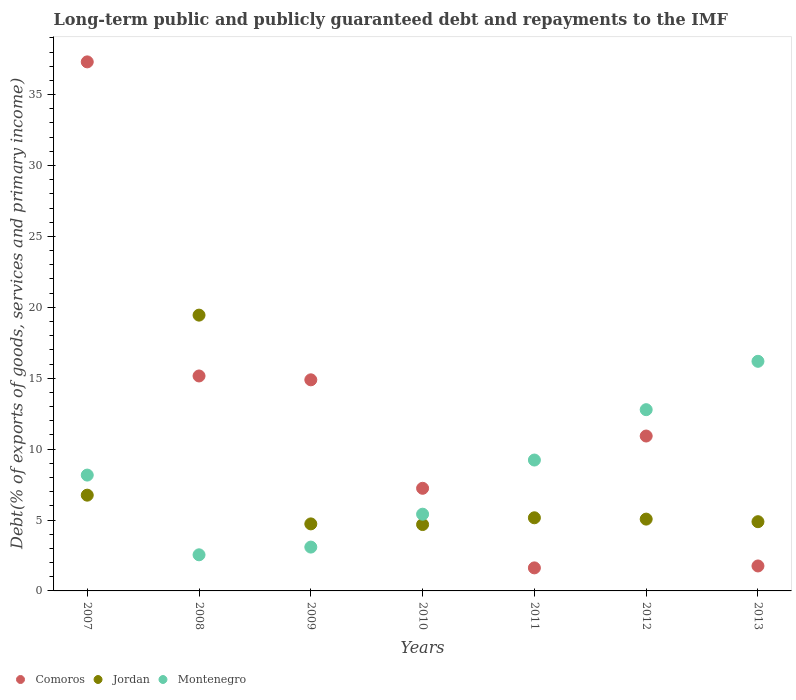How many different coloured dotlines are there?
Your response must be concise. 3. Is the number of dotlines equal to the number of legend labels?
Your answer should be compact. Yes. What is the debt and repayments in Jordan in 2013?
Provide a short and direct response. 4.88. Across all years, what is the maximum debt and repayments in Comoros?
Provide a succinct answer. 37.31. Across all years, what is the minimum debt and repayments in Montenegro?
Your answer should be very brief. 2.55. In which year was the debt and repayments in Jordan maximum?
Offer a terse response. 2008. In which year was the debt and repayments in Comoros minimum?
Provide a short and direct response. 2011. What is the total debt and repayments in Montenegro in the graph?
Make the answer very short. 57.42. What is the difference between the debt and repayments in Jordan in 2008 and that in 2012?
Give a very brief answer. 14.38. What is the difference between the debt and repayments in Comoros in 2011 and the debt and repayments in Jordan in 2012?
Your answer should be compact. -3.44. What is the average debt and repayments in Comoros per year?
Offer a very short reply. 12.7. In the year 2013, what is the difference between the debt and repayments in Comoros and debt and repayments in Montenegro?
Ensure brevity in your answer.  -14.43. In how many years, is the debt and repayments in Jordan greater than 27 %?
Your answer should be very brief. 0. What is the ratio of the debt and repayments in Jordan in 2011 to that in 2013?
Ensure brevity in your answer.  1.06. Is the difference between the debt and repayments in Comoros in 2007 and 2012 greater than the difference between the debt and repayments in Montenegro in 2007 and 2012?
Ensure brevity in your answer.  Yes. What is the difference between the highest and the second highest debt and repayments in Montenegro?
Provide a short and direct response. 3.41. What is the difference between the highest and the lowest debt and repayments in Comoros?
Your response must be concise. 35.68. In how many years, is the debt and repayments in Montenegro greater than the average debt and repayments in Montenegro taken over all years?
Offer a terse response. 3. Is the sum of the debt and repayments in Comoros in 2008 and 2010 greater than the maximum debt and repayments in Montenegro across all years?
Keep it short and to the point. Yes. Is it the case that in every year, the sum of the debt and repayments in Jordan and debt and repayments in Montenegro  is greater than the debt and repayments in Comoros?
Your answer should be compact. No. Are the values on the major ticks of Y-axis written in scientific E-notation?
Your answer should be very brief. No. How many legend labels are there?
Keep it short and to the point. 3. What is the title of the graph?
Offer a very short reply. Long-term public and publicly guaranteed debt and repayments to the IMF. Does "Greece" appear as one of the legend labels in the graph?
Provide a short and direct response. No. What is the label or title of the Y-axis?
Ensure brevity in your answer.  Debt(% of exports of goods, services and primary income). What is the Debt(% of exports of goods, services and primary income) in Comoros in 2007?
Keep it short and to the point. 37.31. What is the Debt(% of exports of goods, services and primary income) in Jordan in 2007?
Provide a succinct answer. 6.75. What is the Debt(% of exports of goods, services and primary income) in Montenegro in 2007?
Make the answer very short. 8.17. What is the Debt(% of exports of goods, services and primary income) of Comoros in 2008?
Your answer should be compact. 15.16. What is the Debt(% of exports of goods, services and primary income) of Jordan in 2008?
Provide a short and direct response. 19.45. What is the Debt(% of exports of goods, services and primary income) of Montenegro in 2008?
Provide a succinct answer. 2.55. What is the Debt(% of exports of goods, services and primary income) of Comoros in 2009?
Your answer should be very brief. 14.89. What is the Debt(% of exports of goods, services and primary income) in Jordan in 2009?
Make the answer very short. 4.73. What is the Debt(% of exports of goods, services and primary income) in Montenegro in 2009?
Your answer should be compact. 3.09. What is the Debt(% of exports of goods, services and primary income) of Comoros in 2010?
Offer a very short reply. 7.24. What is the Debt(% of exports of goods, services and primary income) of Jordan in 2010?
Ensure brevity in your answer.  4.68. What is the Debt(% of exports of goods, services and primary income) of Montenegro in 2010?
Make the answer very short. 5.41. What is the Debt(% of exports of goods, services and primary income) of Comoros in 2011?
Give a very brief answer. 1.62. What is the Debt(% of exports of goods, services and primary income) in Jordan in 2011?
Ensure brevity in your answer.  5.16. What is the Debt(% of exports of goods, services and primary income) in Montenegro in 2011?
Offer a very short reply. 9.23. What is the Debt(% of exports of goods, services and primary income) of Comoros in 2012?
Your response must be concise. 10.92. What is the Debt(% of exports of goods, services and primary income) in Jordan in 2012?
Your answer should be compact. 5.06. What is the Debt(% of exports of goods, services and primary income) of Montenegro in 2012?
Your answer should be very brief. 12.78. What is the Debt(% of exports of goods, services and primary income) of Comoros in 2013?
Offer a very short reply. 1.76. What is the Debt(% of exports of goods, services and primary income) in Jordan in 2013?
Provide a short and direct response. 4.88. What is the Debt(% of exports of goods, services and primary income) of Montenegro in 2013?
Make the answer very short. 16.19. Across all years, what is the maximum Debt(% of exports of goods, services and primary income) of Comoros?
Your answer should be compact. 37.31. Across all years, what is the maximum Debt(% of exports of goods, services and primary income) of Jordan?
Keep it short and to the point. 19.45. Across all years, what is the maximum Debt(% of exports of goods, services and primary income) of Montenegro?
Ensure brevity in your answer.  16.19. Across all years, what is the minimum Debt(% of exports of goods, services and primary income) of Comoros?
Your answer should be very brief. 1.62. Across all years, what is the minimum Debt(% of exports of goods, services and primary income) in Jordan?
Provide a short and direct response. 4.68. Across all years, what is the minimum Debt(% of exports of goods, services and primary income) in Montenegro?
Provide a succinct answer. 2.55. What is the total Debt(% of exports of goods, services and primary income) of Comoros in the graph?
Offer a terse response. 88.9. What is the total Debt(% of exports of goods, services and primary income) of Jordan in the graph?
Provide a succinct answer. 50.71. What is the total Debt(% of exports of goods, services and primary income) in Montenegro in the graph?
Your answer should be very brief. 57.42. What is the difference between the Debt(% of exports of goods, services and primary income) of Comoros in 2007 and that in 2008?
Keep it short and to the point. 22.15. What is the difference between the Debt(% of exports of goods, services and primary income) in Jordan in 2007 and that in 2008?
Your answer should be very brief. -12.7. What is the difference between the Debt(% of exports of goods, services and primary income) of Montenegro in 2007 and that in 2008?
Your response must be concise. 5.62. What is the difference between the Debt(% of exports of goods, services and primary income) in Comoros in 2007 and that in 2009?
Provide a short and direct response. 22.42. What is the difference between the Debt(% of exports of goods, services and primary income) of Jordan in 2007 and that in 2009?
Provide a succinct answer. 2.03. What is the difference between the Debt(% of exports of goods, services and primary income) in Montenegro in 2007 and that in 2009?
Offer a very short reply. 5.08. What is the difference between the Debt(% of exports of goods, services and primary income) of Comoros in 2007 and that in 2010?
Ensure brevity in your answer.  30.07. What is the difference between the Debt(% of exports of goods, services and primary income) in Jordan in 2007 and that in 2010?
Make the answer very short. 2.07. What is the difference between the Debt(% of exports of goods, services and primary income) in Montenegro in 2007 and that in 2010?
Your answer should be compact. 2.76. What is the difference between the Debt(% of exports of goods, services and primary income) in Comoros in 2007 and that in 2011?
Offer a very short reply. 35.68. What is the difference between the Debt(% of exports of goods, services and primary income) of Jordan in 2007 and that in 2011?
Keep it short and to the point. 1.6. What is the difference between the Debt(% of exports of goods, services and primary income) of Montenegro in 2007 and that in 2011?
Offer a very short reply. -1.06. What is the difference between the Debt(% of exports of goods, services and primary income) in Comoros in 2007 and that in 2012?
Make the answer very short. 26.39. What is the difference between the Debt(% of exports of goods, services and primary income) in Jordan in 2007 and that in 2012?
Provide a short and direct response. 1.69. What is the difference between the Debt(% of exports of goods, services and primary income) in Montenegro in 2007 and that in 2012?
Your answer should be very brief. -4.61. What is the difference between the Debt(% of exports of goods, services and primary income) in Comoros in 2007 and that in 2013?
Ensure brevity in your answer.  35.55. What is the difference between the Debt(% of exports of goods, services and primary income) in Jordan in 2007 and that in 2013?
Offer a terse response. 1.87. What is the difference between the Debt(% of exports of goods, services and primary income) in Montenegro in 2007 and that in 2013?
Make the answer very short. -8.02. What is the difference between the Debt(% of exports of goods, services and primary income) of Comoros in 2008 and that in 2009?
Give a very brief answer. 0.27. What is the difference between the Debt(% of exports of goods, services and primary income) in Jordan in 2008 and that in 2009?
Provide a short and direct response. 14.72. What is the difference between the Debt(% of exports of goods, services and primary income) of Montenegro in 2008 and that in 2009?
Provide a short and direct response. -0.54. What is the difference between the Debt(% of exports of goods, services and primary income) in Comoros in 2008 and that in 2010?
Offer a very short reply. 7.92. What is the difference between the Debt(% of exports of goods, services and primary income) in Jordan in 2008 and that in 2010?
Your answer should be very brief. 14.77. What is the difference between the Debt(% of exports of goods, services and primary income) in Montenegro in 2008 and that in 2010?
Offer a terse response. -2.86. What is the difference between the Debt(% of exports of goods, services and primary income) of Comoros in 2008 and that in 2011?
Offer a very short reply. 13.53. What is the difference between the Debt(% of exports of goods, services and primary income) of Jordan in 2008 and that in 2011?
Ensure brevity in your answer.  14.29. What is the difference between the Debt(% of exports of goods, services and primary income) in Montenegro in 2008 and that in 2011?
Offer a terse response. -6.68. What is the difference between the Debt(% of exports of goods, services and primary income) of Comoros in 2008 and that in 2012?
Your answer should be very brief. 4.24. What is the difference between the Debt(% of exports of goods, services and primary income) in Jordan in 2008 and that in 2012?
Your response must be concise. 14.38. What is the difference between the Debt(% of exports of goods, services and primary income) in Montenegro in 2008 and that in 2012?
Keep it short and to the point. -10.24. What is the difference between the Debt(% of exports of goods, services and primary income) of Comoros in 2008 and that in 2013?
Give a very brief answer. 13.4. What is the difference between the Debt(% of exports of goods, services and primary income) in Jordan in 2008 and that in 2013?
Offer a terse response. 14.57. What is the difference between the Debt(% of exports of goods, services and primary income) of Montenegro in 2008 and that in 2013?
Provide a succinct answer. -13.65. What is the difference between the Debt(% of exports of goods, services and primary income) of Comoros in 2009 and that in 2010?
Offer a very short reply. 7.65. What is the difference between the Debt(% of exports of goods, services and primary income) in Jordan in 2009 and that in 2010?
Your response must be concise. 0.05. What is the difference between the Debt(% of exports of goods, services and primary income) in Montenegro in 2009 and that in 2010?
Make the answer very short. -2.32. What is the difference between the Debt(% of exports of goods, services and primary income) of Comoros in 2009 and that in 2011?
Keep it short and to the point. 13.26. What is the difference between the Debt(% of exports of goods, services and primary income) of Jordan in 2009 and that in 2011?
Keep it short and to the point. -0.43. What is the difference between the Debt(% of exports of goods, services and primary income) of Montenegro in 2009 and that in 2011?
Provide a succinct answer. -6.14. What is the difference between the Debt(% of exports of goods, services and primary income) of Comoros in 2009 and that in 2012?
Your answer should be very brief. 3.96. What is the difference between the Debt(% of exports of goods, services and primary income) of Jordan in 2009 and that in 2012?
Offer a very short reply. -0.34. What is the difference between the Debt(% of exports of goods, services and primary income) in Montenegro in 2009 and that in 2012?
Your answer should be very brief. -9.69. What is the difference between the Debt(% of exports of goods, services and primary income) in Comoros in 2009 and that in 2013?
Your response must be concise. 13.13. What is the difference between the Debt(% of exports of goods, services and primary income) in Jordan in 2009 and that in 2013?
Keep it short and to the point. -0.15. What is the difference between the Debt(% of exports of goods, services and primary income) of Montenegro in 2009 and that in 2013?
Keep it short and to the point. -13.1. What is the difference between the Debt(% of exports of goods, services and primary income) in Comoros in 2010 and that in 2011?
Offer a terse response. 5.61. What is the difference between the Debt(% of exports of goods, services and primary income) of Jordan in 2010 and that in 2011?
Keep it short and to the point. -0.48. What is the difference between the Debt(% of exports of goods, services and primary income) in Montenegro in 2010 and that in 2011?
Make the answer very short. -3.82. What is the difference between the Debt(% of exports of goods, services and primary income) of Comoros in 2010 and that in 2012?
Ensure brevity in your answer.  -3.69. What is the difference between the Debt(% of exports of goods, services and primary income) in Jordan in 2010 and that in 2012?
Ensure brevity in your answer.  -0.38. What is the difference between the Debt(% of exports of goods, services and primary income) of Montenegro in 2010 and that in 2012?
Your response must be concise. -7.37. What is the difference between the Debt(% of exports of goods, services and primary income) of Comoros in 2010 and that in 2013?
Offer a terse response. 5.48. What is the difference between the Debt(% of exports of goods, services and primary income) in Jordan in 2010 and that in 2013?
Provide a succinct answer. -0.2. What is the difference between the Debt(% of exports of goods, services and primary income) of Montenegro in 2010 and that in 2013?
Provide a succinct answer. -10.78. What is the difference between the Debt(% of exports of goods, services and primary income) in Comoros in 2011 and that in 2012?
Make the answer very short. -9.3. What is the difference between the Debt(% of exports of goods, services and primary income) in Jordan in 2011 and that in 2012?
Your answer should be compact. 0.09. What is the difference between the Debt(% of exports of goods, services and primary income) in Montenegro in 2011 and that in 2012?
Give a very brief answer. -3.55. What is the difference between the Debt(% of exports of goods, services and primary income) of Comoros in 2011 and that in 2013?
Offer a very short reply. -0.14. What is the difference between the Debt(% of exports of goods, services and primary income) of Jordan in 2011 and that in 2013?
Your answer should be compact. 0.28. What is the difference between the Debt(% of exports of goods, services and primary income) in Montenegro in 2011 and that in 2013?
Offer a very short reply. -6.96. What is the difference between the Debt(% of exports of goods, services and primary income) in Comoros in 2012 and that in 2013?
Offer a very short reply. 9.16. What is the difference between the Debt(% of exports of goods, services and primary income) in Jordan in 2012 and that in 2013?
Ensure brevity in your answer.  0.18. What is the difference between the Debt(% of exports of goods, services and primary income) of Montenegro in 2012 and that in 2013?
Your answer should be very brief. -3.41. What is the difference between the Debt(% of exports of goods, services and primary income) of Comoros in 2007 and the Debt(% of exports of goods, services and primary income) of Jordan in 2008?
Your answer should be very brief. 17.86. What is the difference between the Debt(% of exports of goods, services and primary income) in Comoros in 2007 and the Debt(% of exports of goods, services and primary income) in Montenegro in 2008?
Make the answer very short. 34.76. What is the difference between the Debt(% of exports of goods, services and primary income) in Jordan in 2007 and the Debt(% of exports of goods, services and primary income) in Montenegro in 2008?
Your response must be concise. 4.21. What is the difference between the Debt(% of exports of goods, services and primary income) of Comoros in 2007 and the Debt(% of exports of goods, services and primary income) of Jordan in 2009?
Keep it short and to the point. 32.58. What is the difference between the Debt(% of exports of goods, services and primary income) of Comoros in 2007 and the Debt(% of exports of goods, services and primary income) of Montenegro in 2009?
Offer a terse response. 34.22. What is the difference between the Debt(% of exports of goods, services and primary income) of Jordan in 2007 and the Debt(% of exports of goods, services and primary income) of Montenegro in 2009?
Make the answer very short. 3.66. What is the difference between the Debt(% of exports of goods, services and primary income) of Comoros in 2007 and the Debt(% of exports of goods, services and primary income) of Jordan in 2010?
Provide a succinct answer. 32.63. What is the difference between the Debt(% of exports of goods, services and primary income) in Comoros in 2007 and the Debt(% of exports of goods, services and primary income) in Montenegro in 2010?
Offer a very short reply. 31.9. What is the difference between the Debt(% of exports of goods, services and primary income) of Jordan in 2007 and the Debt(% of exports of goods, services and primary income) of Montenegro in 2010?
Make the answer very short. 1.34. What is the difference between the Debt(% of exports of goods, services and primary income) in Comoros in 2007 and the Debt(% of exports of goods, services and primary income) in Jordan in 2011?
Keep it short and to the point. 32.15. What is the difference between the Debt(% of exports of goods, services and primary income) of Comoros in 2007 and the Debt(% of exports of goods, services and primary income) of Montenegro in 2011?
Give a very brief answer. 28.08. What is the difference between the Debt(% of exports of goods, services and primary income) of Jordan in 2007 and the Debt(% of exports of goods, services and primary income) of Montenegro in 2011?
Your answer should be very brief. -2.48. What is the difference between the Debt(% of exports of goods, services and primary income) of Comoros in 2007 and the Debt(% of exports of goods, services and primary income) of Jordan in 2012?
Ensure brevity in your answer.  32.24. What is the difference between the Debt(% of exports of goods, services and primary income) in Comoros in 2007 and the Debt(% of exports of goods, services and primary income) in Montenegro in 2012?
Your answer should be very brief. 24.53. What is the difference between the Debt(% of exports of goods, services and primary income) of Jordan in 2007 and the Debt(% of exports of goods, services and primary income) of Montenegro in 2012?
Keep it short and to the point. -6.03. What is the difference between the Debt(% of exports of goods, services and primary income) in Comoros in 2007 and the Debt(% of exports of goods, services and primary income) in Jordan in 2013?
Keep it short and to the point. 32.43. What is the difference between the Debt(% of exports of goods, services and primary income) in Comoros in 2007 and the Debt(% of exports of goods, services and primary income) in Montenegro in 2013?
Give a very brief answer. 21.12. What is the difference between the Debt(% of exports of goods, services and primary income) in Jordan in 2007 and the Debt(% of exports of goods, services and primary income) in Montenegro in 2013?
Your answer should be compact. -9.44. What is the difference between the Debt(% of exports of goods, services and primary income) of Comoros in 2008 and the Debt(% of exports of goods, services and primary income) of Jordan in 2009?
Give a very brief answer. 10.43. What is the difference between the Debt(% of exports of goods, services and primary income) in Comoros in 2008 and the Debt(% of exports of goods, services and primary income) in Montenegro in 2009?
Provide a succinct answer. 12.07. What is the difference between the Debt(% of exports of goods, services and primary income) of Jordan in 2008 and the Debt(% of exports of goods, services and primary income) of Montenegro in 2009?
Your answer should be compact. 16.36. What is the difference between the Debt(% of exports of goods, services and primary income) of Comoros in 2008 and the Debt(% of exports of goods, services and primary income) of Jordan in 2010?
Ensure brevity in your answer.  10.48. What is the difference between the Debt(% of exports of goods, services and primary income) in Comoros in 2008 and the Debt(% of exports of goods, services and primary income) in Montenegro in 2010?
Your answer should be very brief. 9.75. What is the difference between the Debt(% of exports of goods, services and primary income) of Jordan in 2008 and the Debt(% of exports of goods, services and primary income) of Montenegro in 2010?
Offer a very short reply. 14.04. What is the difference between the Debt(% of exports of goods, services and primary income) of Comoros in 2008 and the Debt(% of exports of goods, services and primary income) of Jordan in 2011?
Keep it short and to the point. 10. What is the difference between the Debt(% of exports of goods, services and primary income) in Comoros in 2008 and the Debt(% of exports of goods, services and primary income) in Montenegro in 2011?
Offer a terse response. 5.93. What is the difference between the Debt(% of exports of goods, services and primary income) of Jordan in 2008 and the Debt(% of exports of goods, services and primary income) of Montenegro in 2011?
Your response must be concise. 10.22. What is the difference between the Debt(% of exports of goods, services and primary income) in Comoros in 2008 and the Debt(% of exports of goods, services and primary income) in Jordan in 2012?
Provide a succinct answer. 10.09. What is the difference between the Debt(% of exports of goods, services and primary income) in Comoros in 2008 and the Debt(% of exports of goods, services and primary income) in Montenegro in 2012?
Provide a short and direct response. 2.38. What is the difference between the Debt(% of exports of goods, services and primary income) in Jordan in 2008 and the Debt(% of exports of goods, services and primary income) in Montenegro in 2012?
Your response must be concise. 6.67. What is the difference between the Debt(% of exports of goods, services and primary income) of Comoros in 2008 and the Debt(% of exports of goods, services and primary income) of Jordan in 2013?
Your answer should be compact. 10.28. What is the difference between the Debt(% of exports of goods, services and primary income) of Comoros in 2008 and the Debt(% of exports of goods, services and primary income) of Montenegro in 2013?
Offer a terse response. -1.03. What is the difference between the Debt(% of exports of goods, services and primary income) of Jordan in 2008 and the Debt(% of exports of goods, services and primary income) of Montenegro in 2013?
Your response must be concise. 3.26. What is the difference between the Debt(% of exports of goods, services and primary income) of Comoros in 2009 and the Debt(% of exports of goods, services and primary income) of Jordan in 2010?
Give a very brief answer. 10.21. What is the difference between the Debt(% of exports of goods, services and primary income) in Comoros in 2009 and the Debt(% of exports of goods, services and primary income) in Montenegro in 2010?
Provide a succinct answer. 9.48. What is the difference between the Debt(% of exports of goods, services and primary income) in Jordan in 2009 and the Debt(% of exports of goods, services and primary income) in Montenegro in 2010?
Make the answer very short. -0.68. What is the difference between the Debt(% of exports of goods, services and primary income) in Comoros in 2009 and the Debt(% of exports of goods, services and primary income) in Jordan in 2011?
Ensure brevity in your answer.  9.73. What is the difference between the Debt(% of exports of goods, services and primary income) in Comoros in 2009 and the Debt(% of exports of goods, services and primary income) in Montenegro in 2011?
Offer a terse response. 5.66. What is the difference between the Debt(% of exports of goods, services and primary income) of Jordan in 2009 and the Debt(% of exports of goods, services and primary income) of Montenegro in 2011?
Your answer should be compact. -4.5. What is the difference between the Debt(% of exports of goods, services and primary income) in Comoros in 2009 and the Debt(% of exports of goods, services and primary income) in Jordan in 2012?
Offer a very short reply. 9.82. What is the difference between the Debt(% of exports of goods, services and primary income) of Comoros in 2009 and the Debt(% of exports of goods, services and primary income) of Montenegro in 2012?
Offer a very short reply. 2.11. What is the difference between the Debt(% of exports of goods, services and primary income) of Jordan in 2009 and the Debt(% of exports of goods, services and primary income) of Montenegro in 2012?
Provide a short and direct response. -8.05. What is the difference between the Debt(% of exports of goods, services and primary income) in Comoros in 2009 and the Debt(% of exports of goods, services and primary income) in Jordan in 2013?
Your response must be concise. 10.01. What is the difference between the Debt(% of exports of goods, services and primary income) of Comoros in 2009 and the Debt(% of exports of goods, services and primary income) of Montenegro in 2013?
Give a very brief answer. -1.31. What is the difference between the Debt(% of exports of goods, services and primary income) in Jordan in 2009 and the Debt(% of exports of goods, services and primary income) in Montenegro in 2013?
Provide a succinct answer. -11.46. What is the difference between the Debt(% of exports of goods, services and primary income) in Comoros in 2010 and the Debt(% of exports of goods, services and primary income) in Jordan in 2011?
Offer a terse response. 2.08. What is the difference between the Debt(% of exports of goods, services and primary income) of Comoros in 2010 and the Debt(% of exports of goods, services and primary income) of Montenegro in 2011?
Provide a short and direct response. -1.99. What is the difference between the Debt(% of exports of goods, services and primary income) in Jordan in 2010 and the Debt(% of exports of goods, services and primary income) in Montenegro in 2011?
Provide a succinct answer. -4.55. What is the difference between the Debt(% of exports of goods, services and primary income) in Comoros in 2010 and the Debt(% of exports of goods, services and primary income) in Jordan in 2012?
Your answer should be very brief. 2.17. What is the difference between the Debt(% of exports of goods, services and primary income) in Comoros in 2010 and the Debt(% of exports of goods, services and primary income) in Montenegro in 2012?
Provide a succinct answer. -5.54. What is the difference between the Debt(% of exports of goods, services and primary income) of Jordan in 2010 and the Debt(% of exports of goods, services and primary income) of Montenegro in 2012?
Offer a very short reply. -8.1. What is the difference between the Debt(% of exports of goods, services and primary income) in Comoros in 2010 and the Debt(% of exports of goods, services and primary income) in Jordan in 2013?
Make the answer very short. 2.36. What is the difference between the Debt(% of exports of goods, services and primary income) in Comoros in 2010 and the Debt(% of exports of goods, services and primary income) in Montenegro in 2013?
Your response must be concise. -8.95. What is the difference between the Debt(% of exports of goods, services and primary income) of Jordan in 2010 and the Debt(% of exports of goods, services and primary income) of Montenegro in 2013?
Keep it short and to the point. -11.51. What is the difference between the Debt(% of exports of goods, services and primary income) in Comoros in 2011 and the Debt(% of exports of goods, services and primary income) in Jordan in 2012?
Provide a short and direct response. -3.44. What is the difference between the Debt(% of exports of goods, services and primary income) of Comoros in 2011 and the Debt(% of exports of goods, services and primary income) of Montenegro in 2012?
Provide a short and direct response. -11.16. What is the difference between the Debt(% of exports of goods, services and primary income) of Jordan in 2011 and the Debt(% of exports of goods, services and primary income) of Montenegro in 2012?
Keep it short and to the point. -7.62. What is the difference between the Debt(% of exports of goods, services and primary income) in Comoros in 2011 and the Debt(% of exports of goods, services and primary income) in Jordan in 2013?
Your answer should be very brief. -3.26. What is the difference between the Debt(% of exports of goods, services and primary income) in Comoros in 2011 and the Debt(% of exports of goods, services and primary income) in Montenegro in 2013?
Ensure brevity in your answer.  -14.57. What is the difference between the Debt(% of exports of goods, services and primary income) of Jordan in 2011 and the Debt(% of exports of goods, services and primary income) of Montenegro in 2013?
Your answer should be very brief. -11.03. What is the difference between the Debt(% of exports of goods, services and primary income) of Comoros in 2012 and the Debt(% of exports of goods, services and primary income) of Jordan in 2013?
Offer a very short reply. 6.04. What is the difference between the Debt(% of exports of goods, services and primary income) of Comoros in 2012 and the Debt(% of exports of goods, services and primary income) of Montenegro in 2013?
Your response must be concise. -5.27. What is the difference between the Debt(% of exports of goods, services and primary income) of Jordan in 2012 and the Debt(% of exports of goods, services and primary income) of Montenegro in 2013?
Give a very brief answer. -11.13. What is the average Debt(% of exports of goods, services and primary income) of Comoros per year?
Offer a very short reply. 12.7. What is the average Debt(% of exports of goods, services and primary income) in Jordan per year?
Offer a terse response. 7.24. What is the average Debt(% of exports of goods, services and primary income) in Montenegro per year?
Provide a short and direct response. 8.2. In the year 2007, what is the difference between the Debt(% of exports of goods, services and primary income) of Comoros and Debt(% of exports of goods, services and primary income) of Jordan?
Provide a succinct answer. 30.56. In the year 2007, what is the difference between the Debt(% of exports of goods, services and primary income) in Comoros and Debt(% of exports of goods, services and primary income) in Montenegro?
Provide a succinct answer. 29.14. In the year 2007, what is the difference between the Debt(% of exports of goods, services and primary income) of Jordan and Debt(% of exports of goods, services and primary income) of Montenegro?
Your response must be concise. -1.42. In the year 2008, what is the difference between the Debt(% of exports of goods, services and primary income) of Comoros and Debt(% of exports of goods, services and primary income) of Jordan?
Provide a short and direct response. -4.29. In the year 2008, what is the difference between the Debt(% of exports of goods, services and primary income) in Comoros and Debt(% of exports of goods, services and primary income) in Montenegro?
Provide a short and direct response. 12.61. In the year 2008, what is the difference between the Debt(% of exports of goods, services and primary income) of Jordan and Debt(% of exports of goods, services and primary income) of Montenegro?
Offer a very short reply. 16.9. In the year 2009, what is the difference between the Debt(% of exports of goods, services and primary income) in Comoros and Debt(% of exports of goods, services and primary income) in Jordan?
Keep it short and to the point. 10.16. In the year 2009, what is the difference between the Debt(% of exports of goods, services and primary income) in Comoros and Debt(% of exports of goods, services and primary income) in Montenegro?
Make the answer very short. 11.8. In the year 2009, what is the difference between the Debt(% of exports of goods, services and primary income) in Jordan and Debt(% of exports of goods, services and primary income) in Montenegro?
Keep it short and to the point. 1.64. In the year 2010, what is the difference between the Debt(% of exports of goods, services and primary income) of Comoros and Debt(% of exports of goods, services and primary income) of Jordan?
Your answer should be very brief. 2.56. In the year 2010, what is the difference between the Debt(% of exports of goods, services and primary income) in Comoros and Debt(% of exports of goods, services and primary income) in Montenegro?
Offer a terse response. 1.83. In the year 2010, what is the difference between the Debt(% of exports of goods, services and primary income) in Jordan and Debt(% of exports of goods, services and primary income) in Montenegro?
Provide a succinct answer. -0.73. In the year 2011, what is the difference between the Debt(% of exports of goods, services and primary income) in Comoros and Debt(% of exports of goods, services and primary income) in Jordan?
Your answer should be very brief. -3.53. In the year 2011, what is the difference between the Debt(% of exports of goods, services and primary income) in Comoros and Debt(% of exports of goods, services and primary income) in Montenegro?
Ensure brevity in your answer.  -7.61. In the year 2011, what is the difference between the Debt(% of exports of goods, services and primary income) in Jordan and Debt(% of exports of goods, services and primary income) in Montenegro?
Offer a very short reply. -4.07. In the year 2012, what is the difference between the Debt(% of exports of goods, services and primary income) of Comoros and Debt(% of exports of goods, services and primary income) of Jordan?
Your answer should be compact. 5.86. In the year 2012, what is the difference between the Debt(% of exports of goods, services and primary income) in Comoros and Debt(% of exports of goods, services and primary income) in Montenegro?
Your response must be concise. -1.86. In the year 2012, what is the difference between the Debt(% of exports of goods, services and primary income) of Jordan and Debt(% of exports of goods, services and primary income) of Montenegro?
Offer a very short reply. -7.72. In the year 2013, what is the difference between the Debt(% of exports of goods, services and primary income) in Comoros and Debt(% of exports of goods, services and primary income) in Jordan?
Keep it short and to the point. -3.12. In the year 2013, what is the difference between the Debt(% of exports of goods, services and primary income) of Comoros and Debt(% of exports of goods, services and primary income) of Montenegro?
Make the answer very short. -14.43. In the year 2013, what is the difference between the Debt(% of exports of goods, services and primary income) in Jordan and Debt(% of exports of goods, services and primary income) in Montenegro?
Ensure brevity in your answer.  -11.31. What is the ratio of the Debt(% of exports of goods, services and primary income) in Comoros in 2007 to that in 2008?
Your answer should be compact. 2.46. What is the ratio of the Debt(% of exports of goods, services and primary income) in Jordan in 2007 to that in 2008?
Give a very brief answer. 0.35. What is the ratio of the Debt(% of exports of goods, services and primary income) in Montenegro in 2007 to that in 2008?
Your answer should be compact. 3.21. What is the ratio of the Debt(% of exports of goods, services and primary income) of Comoros in 2007 to that in 2009?
Keep it short and to the point. 2.51. What is the ratio of the Debt(% of exports of goods, services and primary income) in Jordan in 2007 to that in 2009?
Provide a succinct answer. 1.43. What is the ratio of the Debt(% of exports of goods, services and primary income) in Montenegro in 2007 to that in 2009?
Your response must be concise. 2.64. What is the ratio of the Debt(% of exports of goods, services and primary income) of Comoros in 2007 to that in 2010?
Give a very brief answer. 5.16. What is the ratio of the Debt(% of exports of goods, services and primary income) of Jordan in 2007 to that in 2010?
Keep it short and to the point. 1.44. What is the ratio of the Debt(% of exports of goods, services and primary income) of Montenegro in 2007 to that in 2010?
Provide a short and direct response. 1.51. What is the ratio of the Debt(% of exports of goods, services and primary income) in Comoros in 2007 to that in 2011?
Your response must be concise. 22.97. What is the ratio of the Debt(% of exports of goods, services and primary income) in Jordan in 2007 to that in 2011?
Make the answer very short. 1.31. What is the ratio of the Debt(% of exports of goods, services and primary income) in Montenegro in 2007 to that in 2011?
Your answer should be very brief. 0.89. What is the ratio of the Debt(% of exports of goods, services and primary income) of Comoros in 2007 to that in 2012?
Make the answer very short. 3.42. What is the ratio of the Debt(% of exports of goods, services and primary income) in Jordan in 2007 to that in 2012?
Provide a short and direct response. 1.33. What is the ratio of the Debt(% of exports of goods, services and primary income) in Montenegro in 2007 to that in 2012?
Your answer should be compact. 0.64. What is the ratio of the Debt(% of exports of goods, services and primary income) in Comoros in 2007 to that in 2013?
Make the answer very short. 21.2. What is the ratio of the Debt(% of exports of goods, services and primary income) of Jordan in 2007 to that in 2013?
Offer a terse response. 1.38. What is the ratio of the Debt(% of exports of goods, services and primary income) of Montenegro in 2007 to that in 2013?
Give a very brief answer. 0.5. What is the ratio of the Debt(% of exports of goods, services and primary income) of Comoros in 2008 to that in 2009?
Offer a terse response. 1.02. What is the ratio of the Debt(% of exports of goods, services and primary income) in Jordan in 2008 to that in 2009?
Offer a very short reply. 4.11. What is the ratio of the Debt(% of exports of goods, services and primary income) of Montenegro in 2008 to that in 2009?
Your answer should be very brief. 0.82. What is the ratio of the Debt(% of exports of goods, services and primary income) of Comoros in 2008 to that in 2010?
Your response must be concise. 2.09. What is the ratio of the Debt(% of exports of goods, services and primary income) of Jordan in 2008 to that in 2010?
Keep it short and to the point. 4.16. What is the ratio of the Debt(% of exports of goods, services and primary income) in Montenegro in 2008 to that in 2010?
Make the answer very short. 0.47. What is the ratio of the Debt(% of exports of goods, services and primary income) in Comoros in 2008 to that in 2011?
Ensure brevity in your answer.  9.33. What is the ratio of the Debt(% of exports of goods, services and primary income) of Jordan in 2008 to that in 2011?
Offer a terse response. 3.77. What is the ratio of the Debt(% of exports of goods, services and primary income) of Montenegro in 2008 to that in 2011?
Offer a terse response. 0.28. What is the ratio of the Debt(% of exports of goods, services and primary income) in Comoros in 2008 to that in 2012?
Your response must be concise. 1.39. What is the ratio of the Debt(% of exports of goods, services and primary income) in Jordan in 2008 to that in 2012?
Make the answer very short. 3.84. What is the ratio of the Debt(% of exports of goods, services and primary income) of Montenegro in 2008 to that in 2012?
Your response must be concise. 0.2. What is the ratio of the Debt(% of exports of goods, services and primary income) of Comoros in 2008 to that in 2013?
Your answer should be compact. 8.61. What is the ratio of the Debt(% of exports of goods, services and primary income) of Jordan in 2008 to that in 2013?
Your response must be concise. 3.98. What is the ratio of the Debt(% of exports of goods, services and primary income) of Montenegro in 2008 to that in 2013?
Offer a very short reply. 0.16. What is the ratio of the Debt(% of exports of goods, services and primary income) of Comoros in 2009 to that in 2010?
Provide a succinct answer. 2.06. What is the ratio of the Debt(% of exports of goods, services and primary income) of Jordan in 2009 to that in 2010?
Make the answer very short. 1.01. What is the ratio of the Debt(% of exports of goods, services and primary income) of Montenegro in 2009 to that in 2010?
Offer a terse response. 0.57. What is the ratio of the Debt(% of exports of goods, services and primary income) of Comoros in 2009 to that in 2011?
Your response must be concise. 9.16. What is the ratio of the Debt(% of exports of goods, services and primary income) in Jordan in 2009 to that in 2011?
Give a very brief answer. 0.92. What is the ratio of the Debt(% of exports of goods, services and primary income) of Montenegro in 2009 to that in 2011?
Offer a terse response. 0.33. What is the ratio of the Debt(% of exports of goods, services and primary income) of Comoros in 2009 to that in 2012?
Keep it short and to the point. 1.36. What is the ratio of the Debt(% of exports of goods, services and primary income) of Jordan in 2009 to that in 2012?
Provide a short and direct response. 0.93. What is the ratio of the Debt(% of exports of goods, services and primary income) in Montenegro in 2009 to that in 2012?
Your answer should be compact. 0.24. What is the ratio of the Debt(% of exports of goods, services and primary income) of Comoros in 2009 to that in 2013?
Offer a terse response. 8.46. What is the ratio of the Debt(% of exports of goods, services and primary income) in Jordan in 2009 to that in 2013?
Your response must be concise. 0.97. What is the ratio of the Debt(% of exports of goods, services and primary income) of Montenegro in 2009 to that in 2013?
Provide a short and direct response. 0.19. What is the ratio of the Debt(% of exports of goods, services and primary income) of Comoros in 2010 to that in 2011?
Keep it short and to the point. 4.46. What is the ratio of the Debt(% of exports of goods, services and primary income) of Jordan in 2010 to that in 2011?
Offer a terse response. 0.91. What is the ratio of the Debt(% of exports of goods, services and primary income) in Montenegro in 2010 to that in 2011?
Ensure brevity in your answer.  0.59. What is the ratio of the Debt(% of exports of goods, services and primary income) in Comoros in 2010 to that in 2012?
Provide a short and direct response. 0.66. What is the ratio of the Debt(% of exports of goods, services and primary income) in Jordan in 2010 to that in 2012?
Your answer should be compact. 0.92. What is the ratio of the Debt(% of exports of goods, services and primary income) of Montenegro in 2010 to that in 2012?
Keep it short and to the point. 0.42. What is the ratio of the Debt(% of exports of goods, services and primary income) of Comoros in 2010 to that in 2013?
Provide a succinct answer. 4.11. What is the ratio of the Debt(% of exports of goods, services and primary income) of Jordan in 2010 to that in 2013?
Your answer should be very brief. 0.96. What is the ratio of the Debt(% of exports of goods, services and primary income) of Montenegro in 2010 to that in 2013?
Ensure brevity in your answer.  0.33. What is the ratio of the Debt(% of exports of goods, services and primary income) of Comoros in 2011 to that in 2012?
Your answer should be very brief. 0.15. What is the ratio of the Debt(% of exports of goods, services and primary income) of Jordan in 2011 to that in 2012?
Your answer should be compact. 1.02. What is the ratio of the Debt(% of exports of goods, services and primary income) of Montenegro in 2011 to that in 2012?
Provide a succinct answer. 0.72. What is the ratio of the Debt(% of exports of goods, services and primary income) in Comoros in 2011 to that in 2013?
Give a very brief answer. 0.92. What is the ratio of the Debt(% of exports of goods, services and primary income) in Jordan in 2011 to that in 2013?
Your answer should be compact. 1.06. What is the ratio of the Debt(% of exports of goods, services and primary income) in Montenegro in 2011 to that in 2013?
Your response must be concise. 0.57. What is the ratio of the Debt(% of exports of goods, services and primary income) in Comoros in 2012 to that in 2013?
Your answer should be very brief. 6.21. What is the ratio of the Debt(% of exports of goods, services and primary income) of Jordan in 2012 to that in 2013?
Provide a succinct answer. 1.04. What is the ratio of the Debt(% of exports of goods, services and primary income) of Montenegro in 2012 to that in 2013?
Give a very brief answer. 0.79. What is the difference between the highest and the second highest Debt(% of exports of goods, services and primary income) of Comoros?
Offer a very short reply. 22.15. What is the difference between the highest and the second highest Debt(% of exports of goods, services and primary income) of Jordan?
Provide a short and direct response. 12.7. What is the difference between the highest and the second highest Debt(% of exports of goods, services and primary income) of Montenegro?
Your response must be concise. 3.41. What is the difference between the highest and the lowest Debt(% of exports of goods, services and primary income) in Comoros?
Your answer should be very brief. 35.68. What is the difference between the highest and the lowest Debt(% of exports of goods, services and primary income) in Jordan?
Provide a succinct answer. 14.77. What is the difference between the highest and the lowest Debt(% of exports of goods, services and primary income) of Montenegro?
Offer a very short reply. 13.65. 